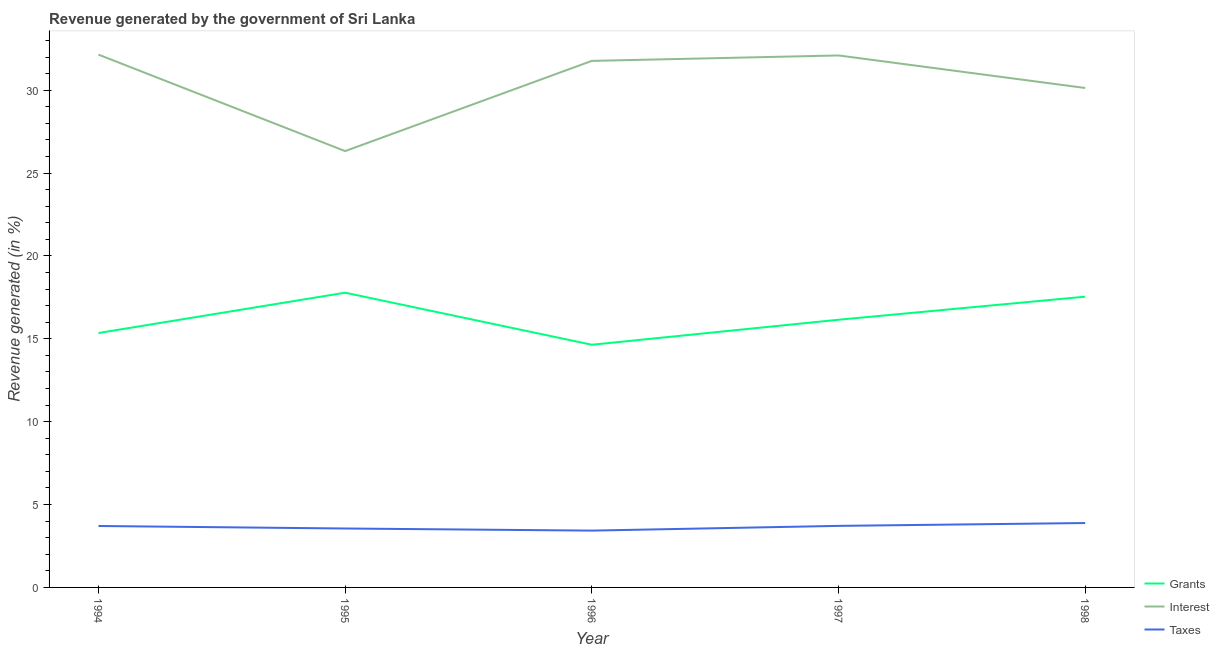What is the percentage of revenue generated by taxes in 1995?
Keep it short and to the point. 3.56. Across all years, what is the maximum percentage of revenue generated by grants?
Offer a very short reply. 17.78. Across all years, what is the minimum percentage of revenue generated by grants?
Make the answer very short. 14.64. In which year was the percentage of revenue generated by interest maximum?
Your answer should be compact. 1994. What is the total percentage of revenue generated by interest in the graph?
Offer a terse response. 152.48. What is the difference between the percentage of revenue generated by taxes in 1995 and that in 1998?
Your response must be concise. -0.33. What is the difference between the percentage of revenue generated by taxes in 1995 and the percentage of revenue generated by interest in 1996?
Offer a terse response. -28.22. What is the average percentage of revenue generated by grants per year?
Your answer should be compact. 16.3. In the year 1997, what is the difference between the percentage of revenue generated by interest and percentage of revenue generated by taxes?
Give a very brief answer. 28.39. In how many years, is the percentage of revenue generated by taxes greater than 2 %?
Provide a succinct answer. 5. What is the ratio of the percentage of revenue generated by interest in 1997 to that in 1998?
Offer a terse response. 1.07. Is the difference between the percentage of revenue generated by interest in 1994 and 1995 greater than the difference between the percentage of revenue generated by taxes in 1994 and 1995?
Make the answer very short. Yes. What is the difference between the highest and the second highest percentage of revenue generated by grants?
Offer a very short reply. 0.24. What is the difference between the highest and the lowest percentage of revenue generated by grants?
Make the answer very short. 3.14. In how many years, is the percentage of revenue generated by grants greater than the average percentage of revenue generated by grants taken over all years?
Offer a terse response. 2. Is the sum of the percentage of revenue generated by interest in 1996 and 1997 greater than the maximum percentage of revenue generated by grants across all years?
Give a very brief answer. Yes. Is it the case that in every year, the sum of the percentage of revenue generated by grants and percentage of revenue generated by interest is greater than the percentage of revenue generated by taxes?
Offer a very short reply. Yes. Is the percentage of revenue generated by taxes strictly less than the percentage of revenue generated by grants over the years?
Offer a very short reply. Yes. Are the values on the major ticks of Y-axis written in scientific E-notation?
Provide a short and direct response. No. Does the graph contain any zero values?
Your answer should be compact. No. Does the graph contain grids?
Your answer should be very brief. No. Where does the legend appear in the graph?
Give a very brief answer. Bottom right. What is the title of the graph?
Keep it short and to the point. Revenue generated by the government of Sri Lanka. Does "Slovak Republic" appear as one of the legend labels in the graph?
Provide a succinct answer. No. What is the label or title of the X-axis?
Your answer should be compact. Year. What is the label or title of the Y-axis?
Provide a succinct answer. Revenue generated (in %). What is the Revenue generated (in %) of Grants in 1994?
Your answer should be very brief. 15.35. What is the Revenue generated (in %) in Interest in 1994?
Provide a succinct answer. 32.15. What is the Revenue generated (in %) in Taxes in 1994?
Offer a very short reply. 3.71. What is the Revenue generated (in %) of Grants in 1995?
Offer a terse response. 17.78. What is the Revenue generated (in %) of Interest in 1995?
Keep it short and to the point. 26.33. What is the Revenue generated (in %) in Taxes in 1995?
Your answer should be very brief. 3.56. What is the Revenue generated (in %) in Grants in 1996?
Offer a very short reply. 14.64. What is the Revenue generated (in %) in Interest in 1996?
Make the answer very short. 31.77. What is the Revenue generated (in %) in Taxes in 1996?
Provide a succinct answer. 3.43. What is the Revenue generated (in %) in Grants in 1997?
Ensure brevity in your answer.  16.15. What is the Revenue generated (in %) of Interest in 1997?
Make the answer very short. 32.1. What is the Revenue generated (in %) in Taxes in 1997?
Offer a terse response. 3.71. What is the Revenue generated (in %) of Grants in 1998?
Offer a very short reply. 17.54. What is the Revenue generated (in %) of Interest in 1998?
Your response must be concise. 30.14. What is the Revenue generated (in %) in Taxes in 1998?
Keep it short and to the point. 3.89. Across all years, what is the maximum Revenue generated (in %) in Grants?
Offer a terse response. 17.78. Across all years, what is the maximum Revenue generated (in %) in Interest?
Your response must be concise. 32.15. Across all years, what is the maximum Revenue generated (in %) in Taxes?
Your answer should be very brief. 3.89. Across all years, what is the minimum Revenue generated (in %) in Grants?
Your answer should be compact. 14.64. Across all years, what is the minimum Revenue generated (in %) of Interest?
Ensure brevity in your answer.  26.33. Across all years, what is the minimum Revenue generated (in %) of Taxes?
Your answer should be very brief. 3.43. What is the total Revenue generated (in %) of Grants in the graph?
Keep it short and to the point. 81.48. What is the total Revenue generated (in %) in Interest in the graph?
Provide a succinct answer. 152.48. What is the total Revenue generated (in %) of Taxes in the graph?
Ensure brevity in your answer.  18.29. What is the difference between the Revenue generated (in %) in Grants in 1994 and that in 1995?
Ensure brevity in your answer.  -2.43. What is the difference between the Revenue generated (in %) in Interest in 1994 and that in 1995?
Your answer should be very brief. 5.82. What is the difference between the Revenue generated (in %) in Taxes in 1994 and that in 1995?
Offer a very short reply. 0.15. What is the difference between the Revenue generated (in %) of Grants in 1994 and that in 1996?
Your response must be concise. 0.71. What is the difference between the Revenue generated (in %) in Interest in 1994 and that in 1996?
Provide a short and direct response. 0.38. What is the difference between the Revenue generated (in %) in Taxes in 1994 and that in 1996?
Your answer should be very brief. 0.28. What is the difference between the Revenue generated (in %) in Grants in 1994 and that in 1997?
Offer a very short reply. -0.8. What is the difference between the Revenue generated (in %) in Interest in 1994 and that in 1997?
Give a very brief answer. 0.05. What is the difference between the Revenue generated (in %) of Taxes in 1994 and that in 1997?
Your response must be concise. -0.01. What is the difference between the Revenue generated (in %) of Grants in 1994 and that in 1998?
Offer a very short reply. -2.19. What is the difference between the Revenue generated (in %) of Interest in 1994 and that in 1998?
Your response must be concise. 2.01. What is the difference between the Revenue generated (in %) in Taxes in 1994 and that in 1998?
Provide a succinct answer. -0.18. What is the difference between the Revenue generated (in %) in Grants in 1995 and that in 1996?
Make the answer very short. 3.14. What is the difference between the Revenue generated (in %) in Interest in 1995 and that in 1996?
Provide a succinct answer. -5.44. What is the difference between the Revenue generated (in %) of Taxes in 1995 and that in 1996?
Provide a succinct answer. 0.13. What is the difference between the Revenue generated (in %) in Grants in 1995 and that in 1997?
Your answer should be compact. 1.63. What is the difference between the Revenue generated (in %) in Interest in 1995 and that in 1997?
Offer a terse response. -5.77. What is the difference between the Revenue generated (in %) of Taxes in 1995 and that in 1997?
Offer a very short reply. -0.16. What is the difference between the Revenue generated (in %) in Grants in 1995 and that in 1998?
Give a very brief answer. 0.24. What is the difference between the Revenue generated (in %) of Interest in 1995 and that in 1998?
Ensure brevity in your answer.  -3.81. What is the difference between the Revenue generated (in %) in Taxes in 1995 and that in 1998?
Ensure brevity in your answer.  -0.33. What is the difference between the Revenue generated (in %) in Grants in 1996 and that in 1997?
Offer a terse response. -1.51. What is the difference between the Revenue generated (in %) of Interest in 1996 and that in 1997?
Keep it short and to the point. -0.33. What is the difference between the Revenue generated (in %) in Taxes in 1996 and that in 1997?
Your response must be concise. -0.29. What is the difference between the Revenue generated (in %) of Grants in 1996 and that in 1998?
Ensure brevity in your answer.  -2.9. What is the difference between the Revenue generated (in %) in Interest in 1996 and that in 1998?
Offer a very short reply. 1.64. What is the difference between the Revenue generated (in %) in Taxes in 1996 and that in 1998?
Give a very brief answer. -0.46. What is the difference between the Revenue generated (in %) in Grants in 1997 and that in 1998?
Give a very brief answer. -1.39. What is the difference between the Revenue generated (in %) of Interest in 1997 and that in 1998?
Make the answer very short. 1.96. What is the difference between the Revenue generated (in %) in Taxes in 1997 and that in 1998?
Your response must be concise. -0.17. What is the difference between the Revenue generated (in %) of Grants in 1994 and the Revenue generated (in %) of Interest in 1995?
Provide a short and direct response. -10.98. What is the difference between the Revenue generated (in %) of Grants in 1994 and the Revenue generated (in %) of Taxes in 1995?
Your answer should be very brief. 11.8. What is the difference between the Revenue generated (in %) of Interest in 1994 and the Revenue generated (in %) of Taxes in 1995?
Your response must be concise. 28.59. What is the difference between the Revenue generated (in %) in Grants in 1994 and the Revenue generated (in %) in Interest in 1996?
Your response must be concise. -16.42. What is the difference between the Revenue generated (in %) in Grants in 1994 and the Revenue generated (in %) in Taxes in 1996?
Keep it short and to the point. 11.92. What is the difference between the Revenue generated (in %) of Interest in 1994 and the Revenue generated (in %) of Taxes in 1996?
Make the answer very short. 28.72. What is the difference between the Revenue generated (in %) in Grants in 1994 and the Revenue generated (in %) in Interest in 1997?
Make the answer very short. -16.75. What is the difference between the Revenue generated (in %) in Grants in 1994 and the Revenue generated (in %) in Taxes in 1997?
Your answer should be very brief. 11.64. What is the difference between the Revenue generated (in %) in Interest in 1994 and the Revenue generated (in %) in Taxes in 1997?
Your answer should be very brief. 28.44. What is the difference between the Revenue generated (in %) in Grants in 1994 and the Revenue generated (in %) in Interest in 1998?
Offer a very short reply. -14.79. What is the difference between the Revenue generated (in %) of Grants in 1994 and the Revenue generated (in %) of Taxes in 1998?
Keep it short and to the point. 11.46. What is the difference between the Revenue generated (in %) of Interest in 1994 and the Revenue generated (in %) of Taxes in 1998?
Keep it short and to the point. 28.26. What is the difference between the Revenue generated (in %) of Grants in 1995 and the Revenue generated (in %) of Interest in 1996?
Give a very brief answer. -13.99. What is the difference between the Revenue generated (in %) in Grants in 1995 and the Revenue generated (in %) in Taxes in 1996?
Your answer should be compact. 14.36. What is the difference between the Revenue generated (in %) in Interest in 1995 and the Revenue generated (in %) in Taxes in 1996?
Keep it short and to the point. 22.9. What is the difference between the Revenue generated (in %) in Grants in 1995 and the Revenue generated (in %) in Interest in 1997?
Your response must be concise. -14.32. What is the difference between the Revenue generated (in %) in Grants in 1995 and the Revenue generated (in %) in Taxes in 1997?
Offer a very short reply. 14.07. What is the difference between the Revenue generated (in %) of Interest in 1995 and the Revenue generated (in %) of Taxes in 1997?
Ensure brevity in your answer.  22.61. What is the difference between the Revenue generated (in %) of Grants in 1995 and the Revenue generated (in %) of Interest in 1998?
Give a very brief answer. -12.35. What is the difference between the Revenue generated (in %) in Grants in 1995 and the Revenue generated (in %) in Taxes in 1998?
Offer a very short reply. 13.9. What is the difference between the Revenue generated (in %) of Interest in 1995 and the Revenue generated (in %) of Taxes in 1998?
Give a very brief answer. 22.44. What is the difference between the Revenue generated (in %) in Grants in 1996 and the Revenue generated (in %) in Interest in 1997?
Provide a succinct answer. -17.46. What is the difference between the Revenue generated (in %) in Grants in 1996 and the Revenue generated (in %) in Taxes in 1997?
Your answer should be very brief. 10.93. What is the difference between the Revenue generated (in %) in Interest in 1996 and the Revenue generated (in %) in Taxes in 1997?
Ensure brevity in your answer.  28.06. What is the difference between the Revenue generated (in %) of Grants in 1996 and the Revenue generated (in %) of Interest in 1998?
Your response must be concise. -15.49. What is the difference between the Revenue generated (in %) in Grants in 1996 and the Revenue generated (in %) in Taxes in 1998?
Your answer should be very brief. 10.76. What is the difference between the Revenue generated (in %) of Interest in 1996 and the Revenue generated (in %) of Taxes in 1998?
Provide a short and direct response. 27.89. What is the difference between the Revenue generated (in %) of Grants in 1997 and the Revenue generated (in %) of Interest in 1998?
Provide a short and direct response. -13.98. What is the difference between the Revenue generated (in %) in Grants in 1997 and the Revenue generated (in %) in Taxes in 1998?
Ensure brevity in your answer.  12.27. What is the difference between the Revenue generated (in %) in Interest in 1997 and the Revenue generated (in %) in Taxes in 1998?
Your response must be concise. 28.21. What is the average Revenue generated (in %) of Grants per year?
Provide a short and direct response. 16.3. What is the average Revenue generated (in %) in Interest per year?
Offer a terse response. 30.5. What is the average Revenue generated (in %) of Taxes per year?
Offer a very short reply. 3.66. In the year 1994, what is the difference between the Revenue generated (in %) of Grants and Revenue generated (in %) of Interest?
Your answer should be very brief. -16.8. In the year 1994, what is the difference between the Revenue generated (in %) in Grants and Revenue generated (in %) in Taxes?
Provide a short and direct response. 11.64. In the year 1994, what is the difference between the Revenue generated (in %) of Interest and Revenue generated (in %) of Taxes?
Offer a very short reply. 28.44. In the year 1995, what is the difference between the Revenue generated (in %) of Grants and Revenue generated (in %) of Interest?
Ensure brevity in your answer.  -8.54. In the year 1995, what is the difference between the Revenue generated (in %) of Grants and Revenue generated (in %) of Taxes?
Your answer should be compact. 14.23. In the year 1995, what is the difference between the Revenue generated (in %) in Interest and Revenue generated (in %) in Taxes?
Your answer should be very brief. 22.77. In the year 1996, what is the difference between the Revenue generated (in %) of Grants and Revenue generated (in %) of Interest?
Ensure brevity in your answer.  -17.13. In the year 1996, what is the difference between the Revenue generated (in %) of Grants and Revenue generated (in %) of Taxes?
Offer a terse response. 11.22. In the year 1996, what is the difference between the Revenue generated (in %) in Interest and Revenue generated (in %) in Taxes?
Keep it short and to the point. 28.34. In the year 1997, what is the difference between the Revenue generated (in %) in Grants and Revenue generated (in %) in Interest?
Ensure brevity in your answer.  -15.95. In the year 1997, what is the difference between the Revenue generated (in %) of Grants and Revenue generated (in %) of Taxes?
Provide a short and direct response. 12.44. In the year 1997, what is the difference between the Revenue generated (in %) of Interest and Revenue generated (in %) of Taxes?
Your response must be concise. 28.39. In the year 1998, what is the difference between the Revenue generated (in %) of Grants and Revenue generated (in %) of Interest?
Ensure brevity in your answer.  -12.59. In the year 1998, what is the difference between the Revenue generated (in %) of Grants and Revenue generated (in %) of Taxes?
Offer a terse response. 13.66. In the year 1998, what is the difference between the Revenue generated (in %) in Interest and Revenue generated (in %) in Taxes?
Your answer should be compact. 26.25. What is the ratio of the Revenue generated (in %) of Grants in 1994 to that in 1995?
Offer a terse response. 0.86. What is the ratio of the Revenue generated (in %) in Interest in 1994 to that in 1995?
Your answer should be very brief. 1.22. What is the ratio of the Revenue generated (in %) in Taxes in 1994 to that in 1995?
Ensure brevity in your answer.  1.04. What is the ratio of the Revenue generated (in %) in Grants in 1994 to that in 1996?
Give a very brief answer. 1.05. What is the ratio of the Revenue generated (in %) in Interest in 1994 to that in 1996?
Give a very brief answer. 1.01. What is the ratio of the Revenue generated (in %) in Taxes in 1994 to that in 1996?
Offer a terse response. 1.08. What is the ratio of the Revenue generated (in %) in Grants in 1994 to that in 1997?
Your answer should be very brief. 0.95. What is the ratio of the Revenue generated (in %) in Interest in 1994 to that in 1997?
Give a very brief answer. 1. What is the ratio of the Revenue generated (in %) of Taxes in 1994 to that in 1997?
Provide a succinct answer. 1. What is the ratio of the Revenue generated (in %) in Grants in 1994 to that in 1998?
Offer a terse response. 0.88. What is the ratio of the Revenue generated (in %) of Interest in 1994 to that in 1998?
Make the answer very short. 1.07. What is the ratio of the Revenue generated (in %) of Taxes in 1994 to that in 1998?
Offer a terse response. 0.95. What is the ratio of the Revenue generated (in %) of Grants in 1995 to that in 1996?
Give a very brief answer. 1.21. What is the ratio of the Revenue generated (in %) in Interest in 1995 to that in 1996?
Keep it short and to the point. 0.83. What is the ratio of the Revenue generated (in %) in Taxes in 1995 to that in 1996?
Offer a terse response. 1.04. What is the ratio of the Revenue generated (in %) of Grants in 1995 to that in 1997?
Offer a very short reply. 1.1. What is the ratio of the Revenue generated (in %) of Interest in 1995 to that in 1997?
Provide a succinct answer. 0.82. What is the ratio of the Revenue generated (in %) of Taxes in 1995 to that in 1997?
Give a very brief answer. 0.96. What is the ratio of the Revenue generated (in %) in Grants in 1995 to that in 1998?
Give a very brief answer. 1.01. What is the ratio of the Revenue generated (in %) of Interest in 1995 to that in 1998?
Your response must be concise. 0.87. What is the ratio of the Revenue generated (in %) in Taxes in 1995 to that in 1998?
Provide a succinct answer. 0.91. What is the ratio of the Revenue generated (in %) of Grants in 1996 to that in 1997?
Ensure brevity in your answer.  0.91. What is the ratio of the Revenue generated (in %) in Interest in 1996 to that in 1997?
Your response must be concise. 0.99. What is the ratio of the Revenue generated (in %) in Grants in 1996 to that in 1998?
Provide a short and direct response. 0.83. What is the ratio of the Revenue generated (in %) in Interest in 1996 to that in 1998?
Offer a terse response. 1.05. What is the ratio of the Revenue generated (in %) of Taxes in 1996 to that in 1998?
Provide a short and direct response. 0.88. What is the ratio of the Revenue generated (in %) of Grants in 1997 to that in 1998?
Offer a very short reply. 0.92. What is the ratio of the Revenue generated (in %) of Interest in 1997 to that in 1998?
Make the answer very short. 1.07. What is the ratio of the Revenue generated (in %) of Taxes in 1997 to that in 1998?
Give a very brief answer. 0.96. What is the difference between the highest and the second highest Revenue generated (in %) in Grants?
Give a very brief answer. 0.24. What is the difference between the highest and the second highest Revenue generated (in %) of Interest?
Your response must be concise. 0.05. What is the difference between the highest and the second highest Revenue generated (in %) of Taxes?
Ensure brevity in your answer.  0.17. What is the difference between the highest and the lowest Revenue generated (in %) of Grants?
Offer a very short reply. 3.14. What is the difference between the highest and the lowest Revenue generated (in %) of Interest?
Your answer should be very brief. 5.82. What is the difference between the highest and the lowest Revenue generated (in %) of Taxes?
Offer a very short reply. 0.46. 